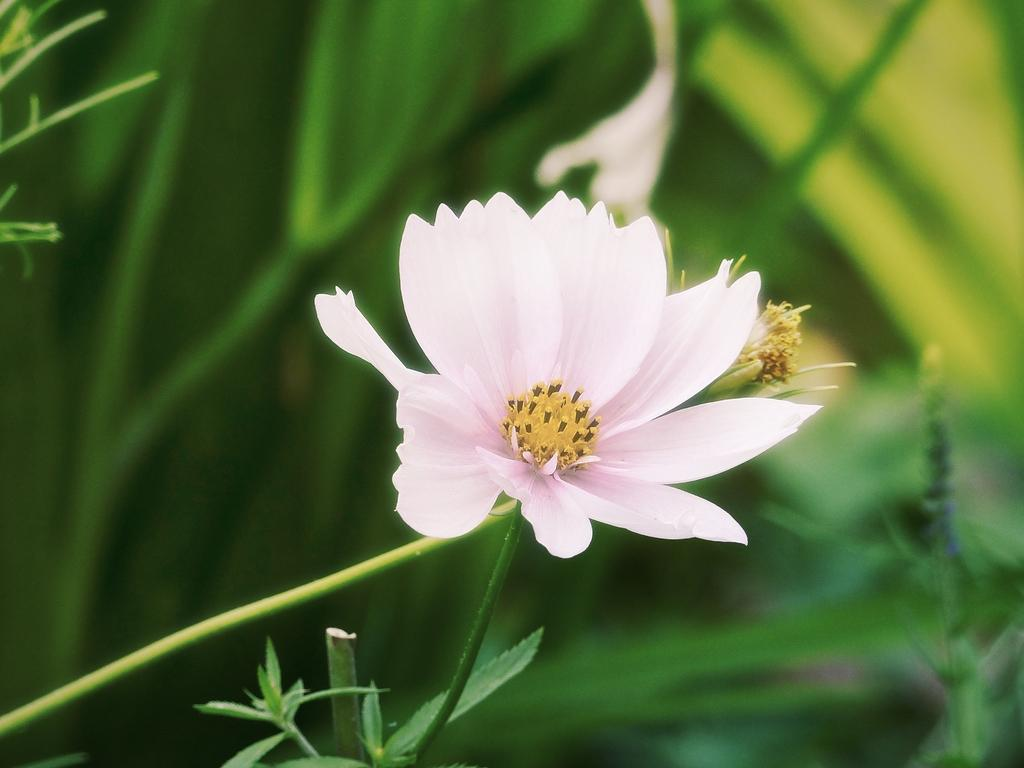What is the main subject of the image? There is a flower in the image. What else can be seen in the image besides the flower? There are leaves in the image. What color is the background of the image? The background of the image is green. How would you describe the quality of the image? The image is slightly blurry in the background. How many cats can be seen playing with steam in the image? There are no cats or steam present in the image; it features a flower and leaves with a green background. 